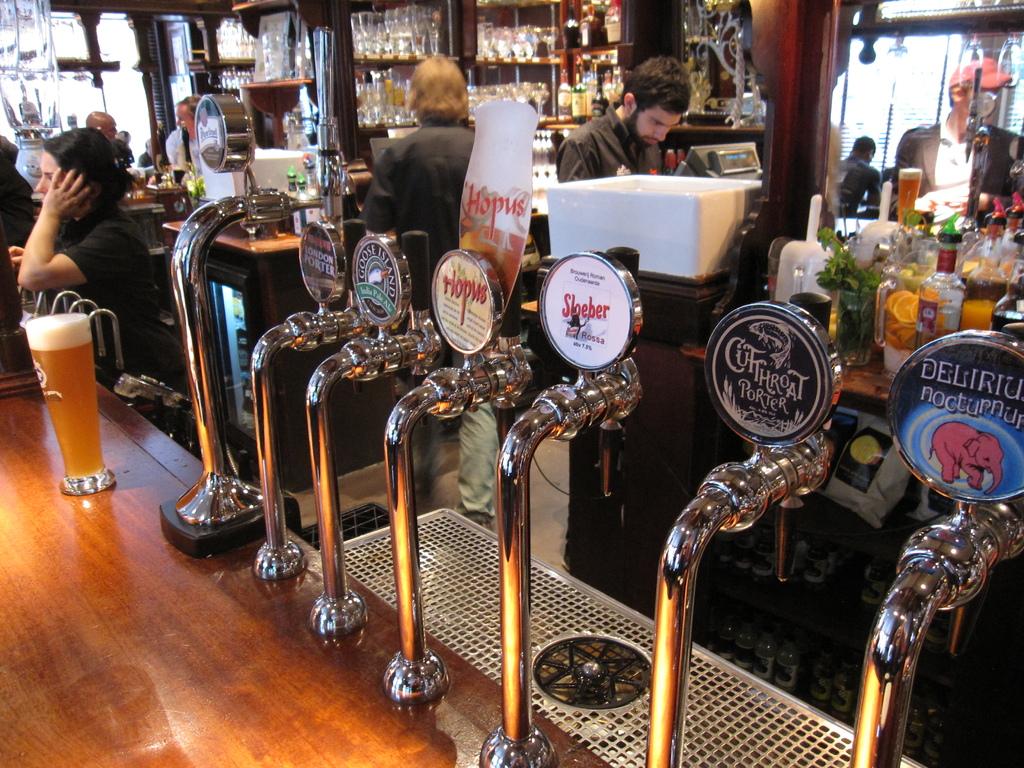The tap with a fish on it is for what brand of porter?
Ensure brevity in your answer.  Unanswerable. 